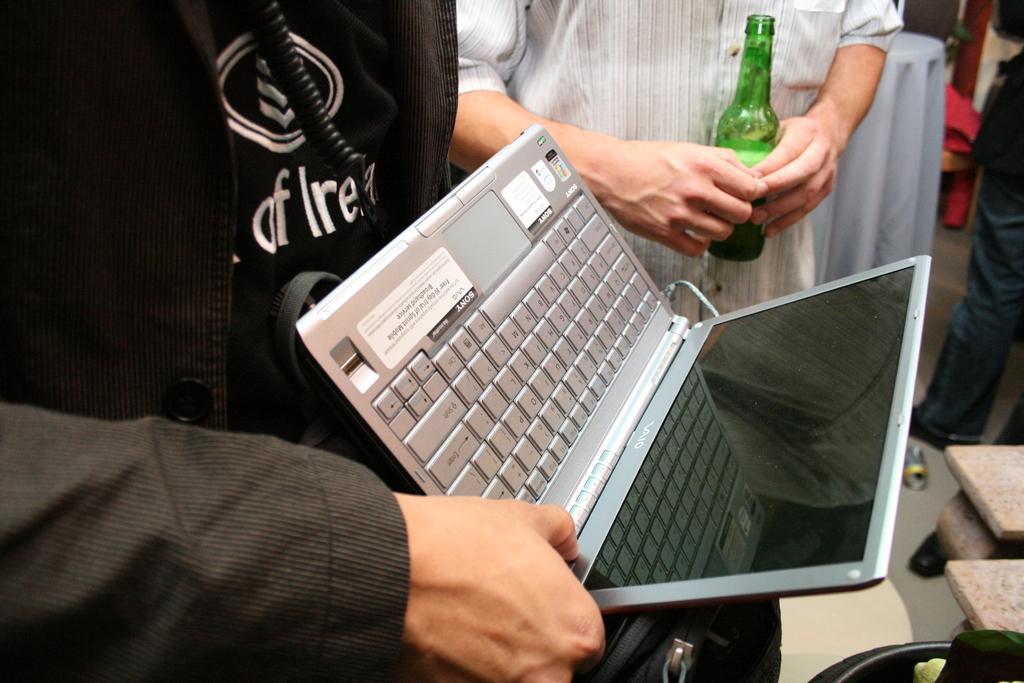How would you summarize this image in a sentence or two? In this image, In the middle there is a laptop which is in ash color and in the left side there is a man standing and holding a laptop and in the background there is a man standing and holding a bottle which is in green color. 